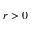<formula> <loc_0><loc_0><loc_500><loc_500>r > 0</formula> 